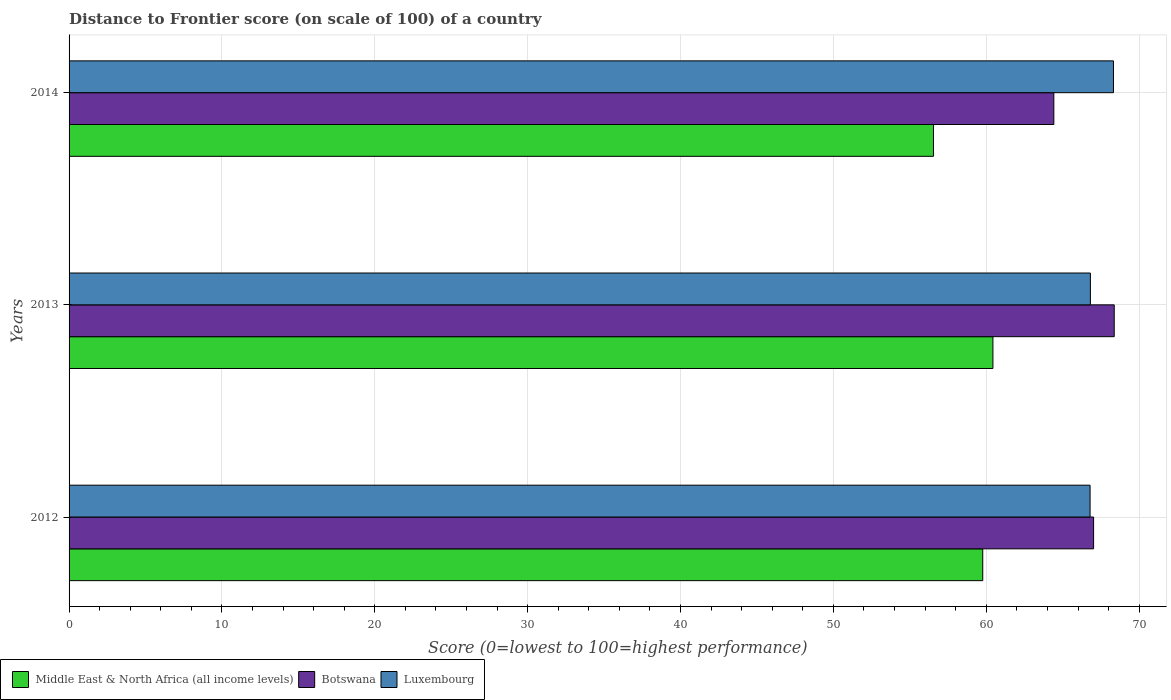How many groups of bars are there?
Your response must be concise. 3. How many bars are there on the 3rd tick from the bottom?
Keep it short and to the point. 3. In how many cases, is the number of bars for a given year not equal to the number of legend labels?
Make the answer very short. 0. What is the distance to frontier score of in Middle East & North Africa (all income levels) in 2014?
Make the answer very short. 56.54. Across all years, what is the maximum distance to frontier score of in Luxembourg?
Keep it short and to the point. 68.32. Across all years, what is the minimum distance to frontier score of in Middle East & North Africa (all income levels)?
Your answer should be compact. 56.54. What is the total distance to frontier score of in Luxembourg in the graph?
Your answer should be compact. 201.92. What is the difference between the distance to frontier score of in Botswana in 2013 and that in 2014?
Provide a succinct answer. 3.95. What is the difference between the distance to frontier score of in Middle East & North Africa (all income levels) in 2014 and the distance to frontier score of in Luxembourg in 2013?
Provide a short and direct response. -10.27. What is the average distance to frontier score of in Middle East & North Africa (all income levels) per year?
Provide a succinct answer. 58.92. In the year 2013, what is the difference between the distance to frontier score of in Botswana and distance to frontier score of in Middle East & North Africa (all income levels)?
Provide a succinct answer. 7.94. What is the ratio of the distance to frontier score of in Middle East & North Africa (all income levels) in 2012 to that in 2014?
Offer a terse response. 1.06. What is the difference between the highest and the second highest distance to frontier score of in Middle East & North Africa (all income levels)?
Offer a very short reply. 0.67. What is the difference between the highest and the lowest distance to frontier score of in Middle East & North Africa (all income levels)?
Offer a terse response. 3.89. In how many years, is the distance to frontier score of in Luxembourg greater than the average distance to frontier score of in Luxembourg taken over all years?
Give a very brief answer. 1. Is the sum of the distance to frontier score of in Botswana in 2012 and 2014 greater than the maximum distance to frontier score of in Luxembourg across all years?
Give a very brief answer. Yes. What does the 1st bar from the top in 2013 represents?
Make the answer very short. Luxembourg. What does the 1st bar from the bottom in 2013 represents?
Offer a terse response. Middle East & North Africa (all income levels). What is the difference between two consecutive major ticks on the X-axis?
Make the answer very short. 10. Are the values on the major ticks of X-axis written in scientific E-notation?
Your answer should be very brief. No. Does the graph contain any zero values?
Your response must be concise. No. Where does the legend appear in the graph?
Provide a succinct answer. Bottom left. How many legend labels are there?
Offer a terse response. 3. What is the title of the graph?
Offer a terse response. Distance to Frontier score (on scale of 100) of a country. What is the label or title of the X-axis?
Provide a succinct answer. Score (0=lowest to 100=highest performance). What is the label or title of the Y-axis?
Ensure brevity in your answer.  Years. What is the Score (0=lowest to 100=highest performance) in Middle East & North Africa (all income levels) in 2012?
Make the answer very short. 59.77. What is the Score (0=lowest to 100=highest performance) of Botswana in 2012?
Ensure brevity in your answer.  67.02. What is the Score (0=lowest to 100=highest performance) of Luxembourg in 2012?
Provide a short and direct response. 66.79. What is the Score (0=lowest to 100=highest performance) of Middle East & North Africa (all income levels) in 2013?
Provide a short and direct response. 60.43. What is the Score (0=lowest to 100=highest performance) of Botswana in 2013?
Make the answer very short. 68.37. What is the Score (0=lowest to 100=highest performance) in Luxembourg in 2013?
Make the answer very short. 66.81. What is the Score (0=lowest to 100=highest performance) of Middle East & North Africa (all income levels) in 2014?
Your answer should be compact. 56.54. What is the Score (0=lowest to 100=highest performance) of Botswana in 2014?
Your response must be concise. 64.42. What is the Score (0=lowest to 100=highest performance) of Luxembourg in 2014?
Provide a short and direct response. 68.32. Across all years, what is the maximum Score (0=lowest to 100=highest performance) in Middle East & North Africa (all income levels)?
Provide a short and direct response. 60.43. Across all years, what is the maximum Score (0=lowest to 100=highest performance) in Botswana?
Keep it short and to the point. 68.37. Across all years, what is the maximum Score (0=lowest to 100=highest performance) of Luxembourg?
Keep it short and to the point. 68.32. Across all years, what is the minimum Score (0=lowest to 100=highest performance) in Middle East & North Africa (all income levels)?
Offer a very short reply. 56.54. Across all years, what is the minimum Score (0=lowest to 100=highest performance) in Botswana?
Keep it short and to the point. 64.42. Across all years, what is the minimum Score (0=lowest to 100=highest performance) in Luxembourg?
Your answer should be very brief. 66.79. What is the total Score (0=lowest to 100=highest performance) in Middle East & North Africa (all income levels) in the graph?
Ensure brevity in your answer.  176.75. What is the total Score (0=lowest to 100=highest performance) in Botswana in the graph?
Your answer should be compact. 199.81. What is the total Score (0=lowest to 100=highest performance) in Luxembourg in the graph?
Provide a succinct answer. 201.92. What is the difference between the Score (0=lowest to 100=highest performance) of Middle East & North Africa (all income levels) in 2012 and that in 2013?
Your response must be concise. -0.67. What is the difference between the Score (0=lowest to 100=highest performance) in Botswana in 2012 and that in 2013?
Offer a terse response. -1.35. What is the difference between the Score (0=lowest to 100=highest performance) of Luxembourg in 2012 and that in 2013?
Keep it short and to the point. -0.02. What is the difference between the Score (0=lowest to 100=highest performance) in Middle East & North Africa (all income levels) in 2012 and that in 2014?
Your response must be concise. 3.22. What is the difference between the Score (0=lowest to 100=highest performance) in Luxembourg in 2012 and that in 2014?
Provide a short and direct response. -1.53. What is the difference between the Score (0=lowest to 100=highest performance) in Middle East & North Africa (all income levels) in 2013 and that in 2014?
Provide a succinct answer. 3.89. What is the difference between the Score (0=lowest to 100=highest performance) of Botswana in 2013 and that in 2014?
Offer a terse response. 3.95. What is the difference between the Score (0=lowest to 100=highest performance) in Luxembourg in 2013 and that in 2014?
Offer a very short reply. -1.51. What is the difference between the Score (0=lowest to 100=highest performance) of Middle East & North Africa (all income levels) in 2012 and the Score (0=lowest to 100=highest performance) of Botswana in 2013?
Give a very brief answer. -8.6. What is the difference between the Score (0=lowest to 100=highest performance) in Middle East & North Africa (all income levels) in 2012 and the Score (0=lowest to 100=highest performance) in Luxembourg in 2013?
Make the answer very short. -7.04. What is the difference between the Score (0=lowest to 100=highest performance) in Botswana in 2012 and the Score (0=lowest to 100=highest performance) in Luxembourg in 2013?
Provide a short and direct response. 0.21. What is the difference between the Score (0=lowest to 100=highest performance) of Middle East & North Africa (all income levels) in 2012 and the Score (0=lowest to 100=highest performance) of Botswana in 2014?
Make the answer very short. -4.65. What is the difference between the Score (0=lowest to 100=highest performance) in Middle East & North Africa (all income levels) in 2012 and the Score (0=lowest to 100=highest performance) in Luxembourg in 2014?
Offer a terse response. -8.55. What is the difference between the Score (0=lowest to 100=highest performance) in Middle East & North Africa (all income levels) in 2013 and the Score (0=lowest to 100=highest performance) in Botswana in 2014?
Your response must be concise. -3.99. What is the difference between the Score (0=lowest to 100=highest performance) of Middle East & North Africa (all income levels) in 2013 and the Score (0=lowest to 100=highest performance) of Luxembourg in 2014?
Provide a succinct answer. -7.89. What is the average Score (0=lowest to 100=highest performance) in Middle East & North Africa (all income levels) per year?
Give a very brief answer. 58.92. What is the average Score (0=lowest to 100=highest performance) of Botswana per year?
Keep it short and to the point. 66.6. What is the average Score (0=lowest to 100=highest performance) of Luxembourg per year?
Provide a short and direct response. 67.31. In the year 2012, what is the difference between the Score (0=lowest to 100=highest performance) of Middle East & North Africa (all income levels) and Score (0=lowest to 100=highest performance) of Botswana?
Your answer should be very brief. -7.25. In the year 2012, what is the difference between the Score (0=lowest to 100=highest performance) of Middle East & North Africa (all income levels) and Score (0=lowest to 100=highest performance) of Luxembourg?
Offer a very short reply. -7.02. In the year 2012, what is the difference between the Score (0=lowest to 100=highest performance) of Botswana and Score (0=lowest to 100=highest performance) of Luxembourg?
Your answer should be very brief. 0.23. In the year 2013, what is the difference between the Score (0=lowest to 100=highest performance) in Middle East & North Africa (all income levels) and Score (0=lowest to 100=highest performance) in Botswana?
Make the answer very short. -7.94. In the year 2013, what is the difference between the Score (0=lowest to 100=highest performance) of Middle East & North Africa (all income levels) and Score (0=lowest to 100=highest performance) of Luxembourg?
Provide a succinct answer. -6.38. In the year 2013, what is the difference between the Score (0=lowest to 100=highest performance) in Botswana and Score (0=lowest to 100=highest performance) in Luxembourg?
Make the answer very short. 1.56. In the year 2014, what is the difference between the Score (0=lowest to 100=highest performance) of Middle East & North Africa (all income levels) and Score (0=lowest to 100=highest performance) of Botswana?
Give a very brief answer. -7.88. In the year 2014, what is the difference between the Score (0=lowest to 100=highest performance) in Middle East & North Africa (all income levels) and Score (0=lowest to 100=highest performance) in Luxembourg?
Make the answer very short. -11.78. What is the ratio of the Score (0=lowest to 100=highest performance) in Botswana in 2012 to that in 2013?
Ensure brevity in your answer.  0.98. What is the ratio of the Score (0=lowest to 100=highest performance) in Middle East & North Africa (all income levels) in 2012 to that in 2014?
Ensure brevity in your answer.  1.06. What is the ratio of the Score (0=lowest to 100=highest performance) in Botswana in 2012 to that in 2014?
Keep it short and to the point. 1.04. What is the ratio of the Score (0=lowest to 100=highest performance) in Luxembourg in 2012 to that in 2014?
Provide a succinct answer. 0.98. What is the ratio of the Score (0=lowest to 100=highest performance) of Middle East & North Africa (all income levels) in 2013 to that in 2014?
Give a very brief answer. 1.07. What is the ratio of the Score (0=lowest to 100=highest performance) of Botswana in 2013 to that in 2014?
Keep it short and to the point. 1.06. What is the ratio of the Score (0=lowest to 100=highest performance) of Luxembourg in 2013 to that in 2014?
Your response must be concise. 0.98. What is the difference between the highest and the second highest Score (0=lowest to 100=highest performance) in Middle East & North Africa (all income levels)?
Provide a short and direct response. 0.67. What is the difference between the highest and the second highest Score (0=lowest to 100=highest performance) in Botswana?
Your answer should be very brief. 1.35. What is the difference between the highest and the second highest Score (0=lowest to 100=highest performance) in Luxembourg?
Give a very brief answer. 1.51. What is the difference between the highest and the lowest Score (0=lowest to 100=highest performance) of Middle East & North Africa (all income levels)?
Keep it short and to the point. 3.89. What is the difference between the highest and the lowest Score (0=lowest to 100=highest performance) in Botswana?
Offer a very short reply. 3.95. What is the difference between the highest and the lowest Score (0=lowest to 100=highest performance) of Luxembourg?
Your answer should be compact. 1.53. 